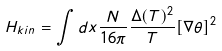<formula> <loc_0><loc_0><loc_500><loc_500>H _ { k i n } = \int d x \frac { N } { 1 6 \pi } \frac { \Delta ( T ) ^ { 2 } } { T } [ \nabla \theta ] ^ { 2 }</formula> 